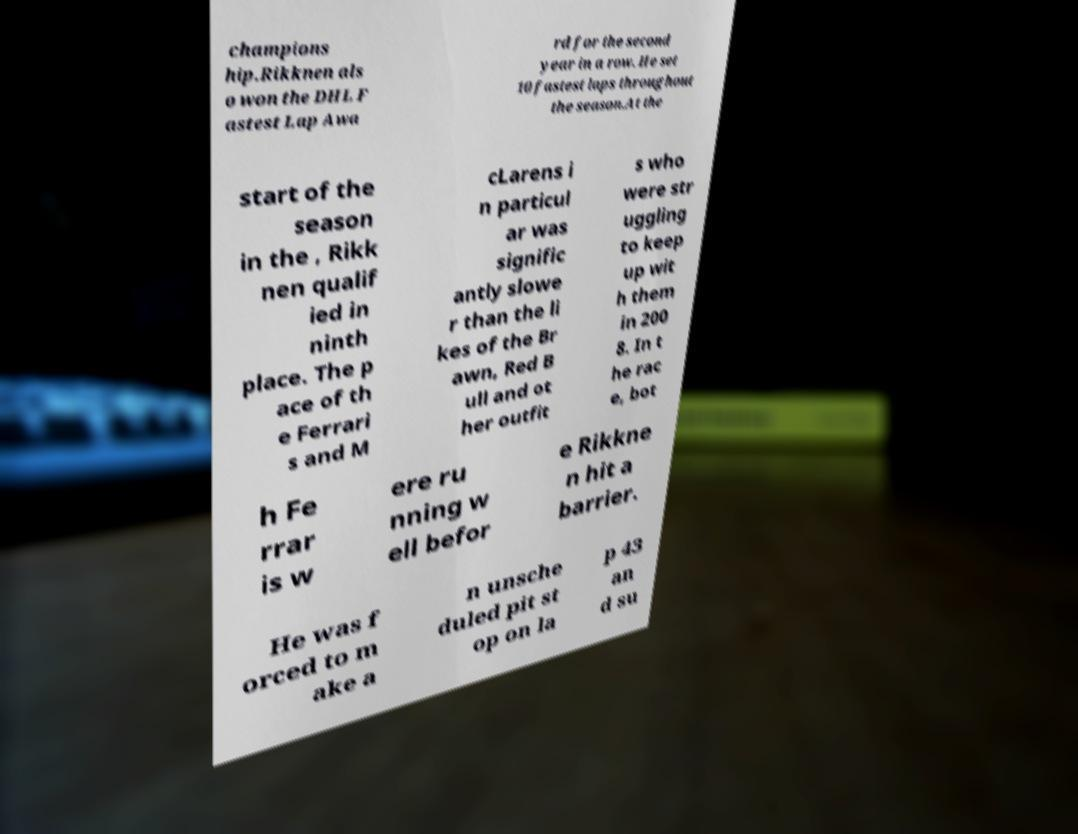Please read and relay the text visible in this image. What does it say? champions hip.Rikknen als o won the DHL F astest Lap Awa rd for the second year in a row. He set 10 fastest laps throughout the season.At the start of the season in the , Rikk nen qualif ied in ninth place. The p ace of th e Ferrari s and M cLarens i n particul ar was signific antly slowe r than the li kes of the Br awn, Red B ull and ot her outfit s who were str uggling to keep up wit h them in 200 8. In t he rac e, bot h Fe rrar is w ere ru nning w ell befor e Rikkne n hit a barrier. He was f orced to m ake a n unsche duled pit st op on la p 43 an d su 